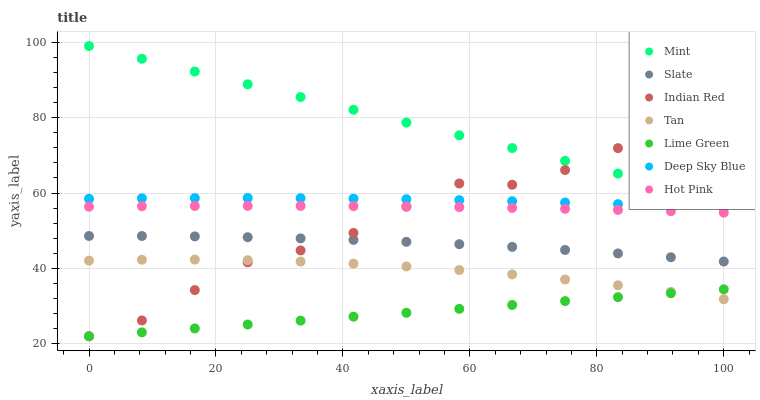Does Lime Green have the minimum area under the curve?
Answer yes or no. Yes. Does Mint have the maximum area under the curve?
Answer yes or no. Yes. Does Slate have the minimum area under the curve?
Answer yes or no. No. Does Slate have the maximum area under the curve?
Answer yes or no. No. Is Lime Green the smoothest?
Answer yes or no. Yes. Is Indian Red the roughest?
Answer yes or no. Yes. Is Mint the smoothest?
Answer yes or no. No. Is Mint the roughest?
Answer yes or no. No. Does Indian Red have the lowest value?
Answer yes or no. Yes. Does Slate have the lowest value?
Answer yes or no. No. Does Mint have the highest value?
Answer yes or no. Yes. Does Slate have the highest value?
Answer yes or no. No. Is Deep Sky Blue less than Mint?
Answer yes or no. Yes. Is Hot Pink greater than Slate?
Answer yes or no. Yes. Does Indian Red intersect Lime Green?
Answer yes or no. Yes. Is Indian Red less than Lime Green?
Answer yes or no. No. Is Indian Red greater than Lime Green?
Answer yes or no. No. Does Deep Sky Blue intersect Mint?
Answer yes or no. No. 